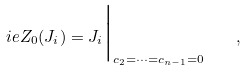Convert formula to latex. <formula><loc_0><loc_0><loc_500><loc_500>\L i e { Z _ { 0 } } ( J _ { i } ) = J _ { i } \Big | _ { { c _ { 2 } = \cdots = c _ { n - 1 } = 0 } } \quad ,</formula> 